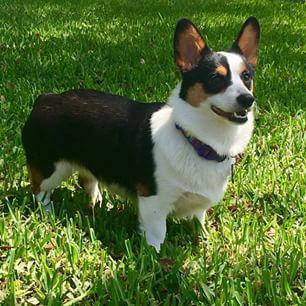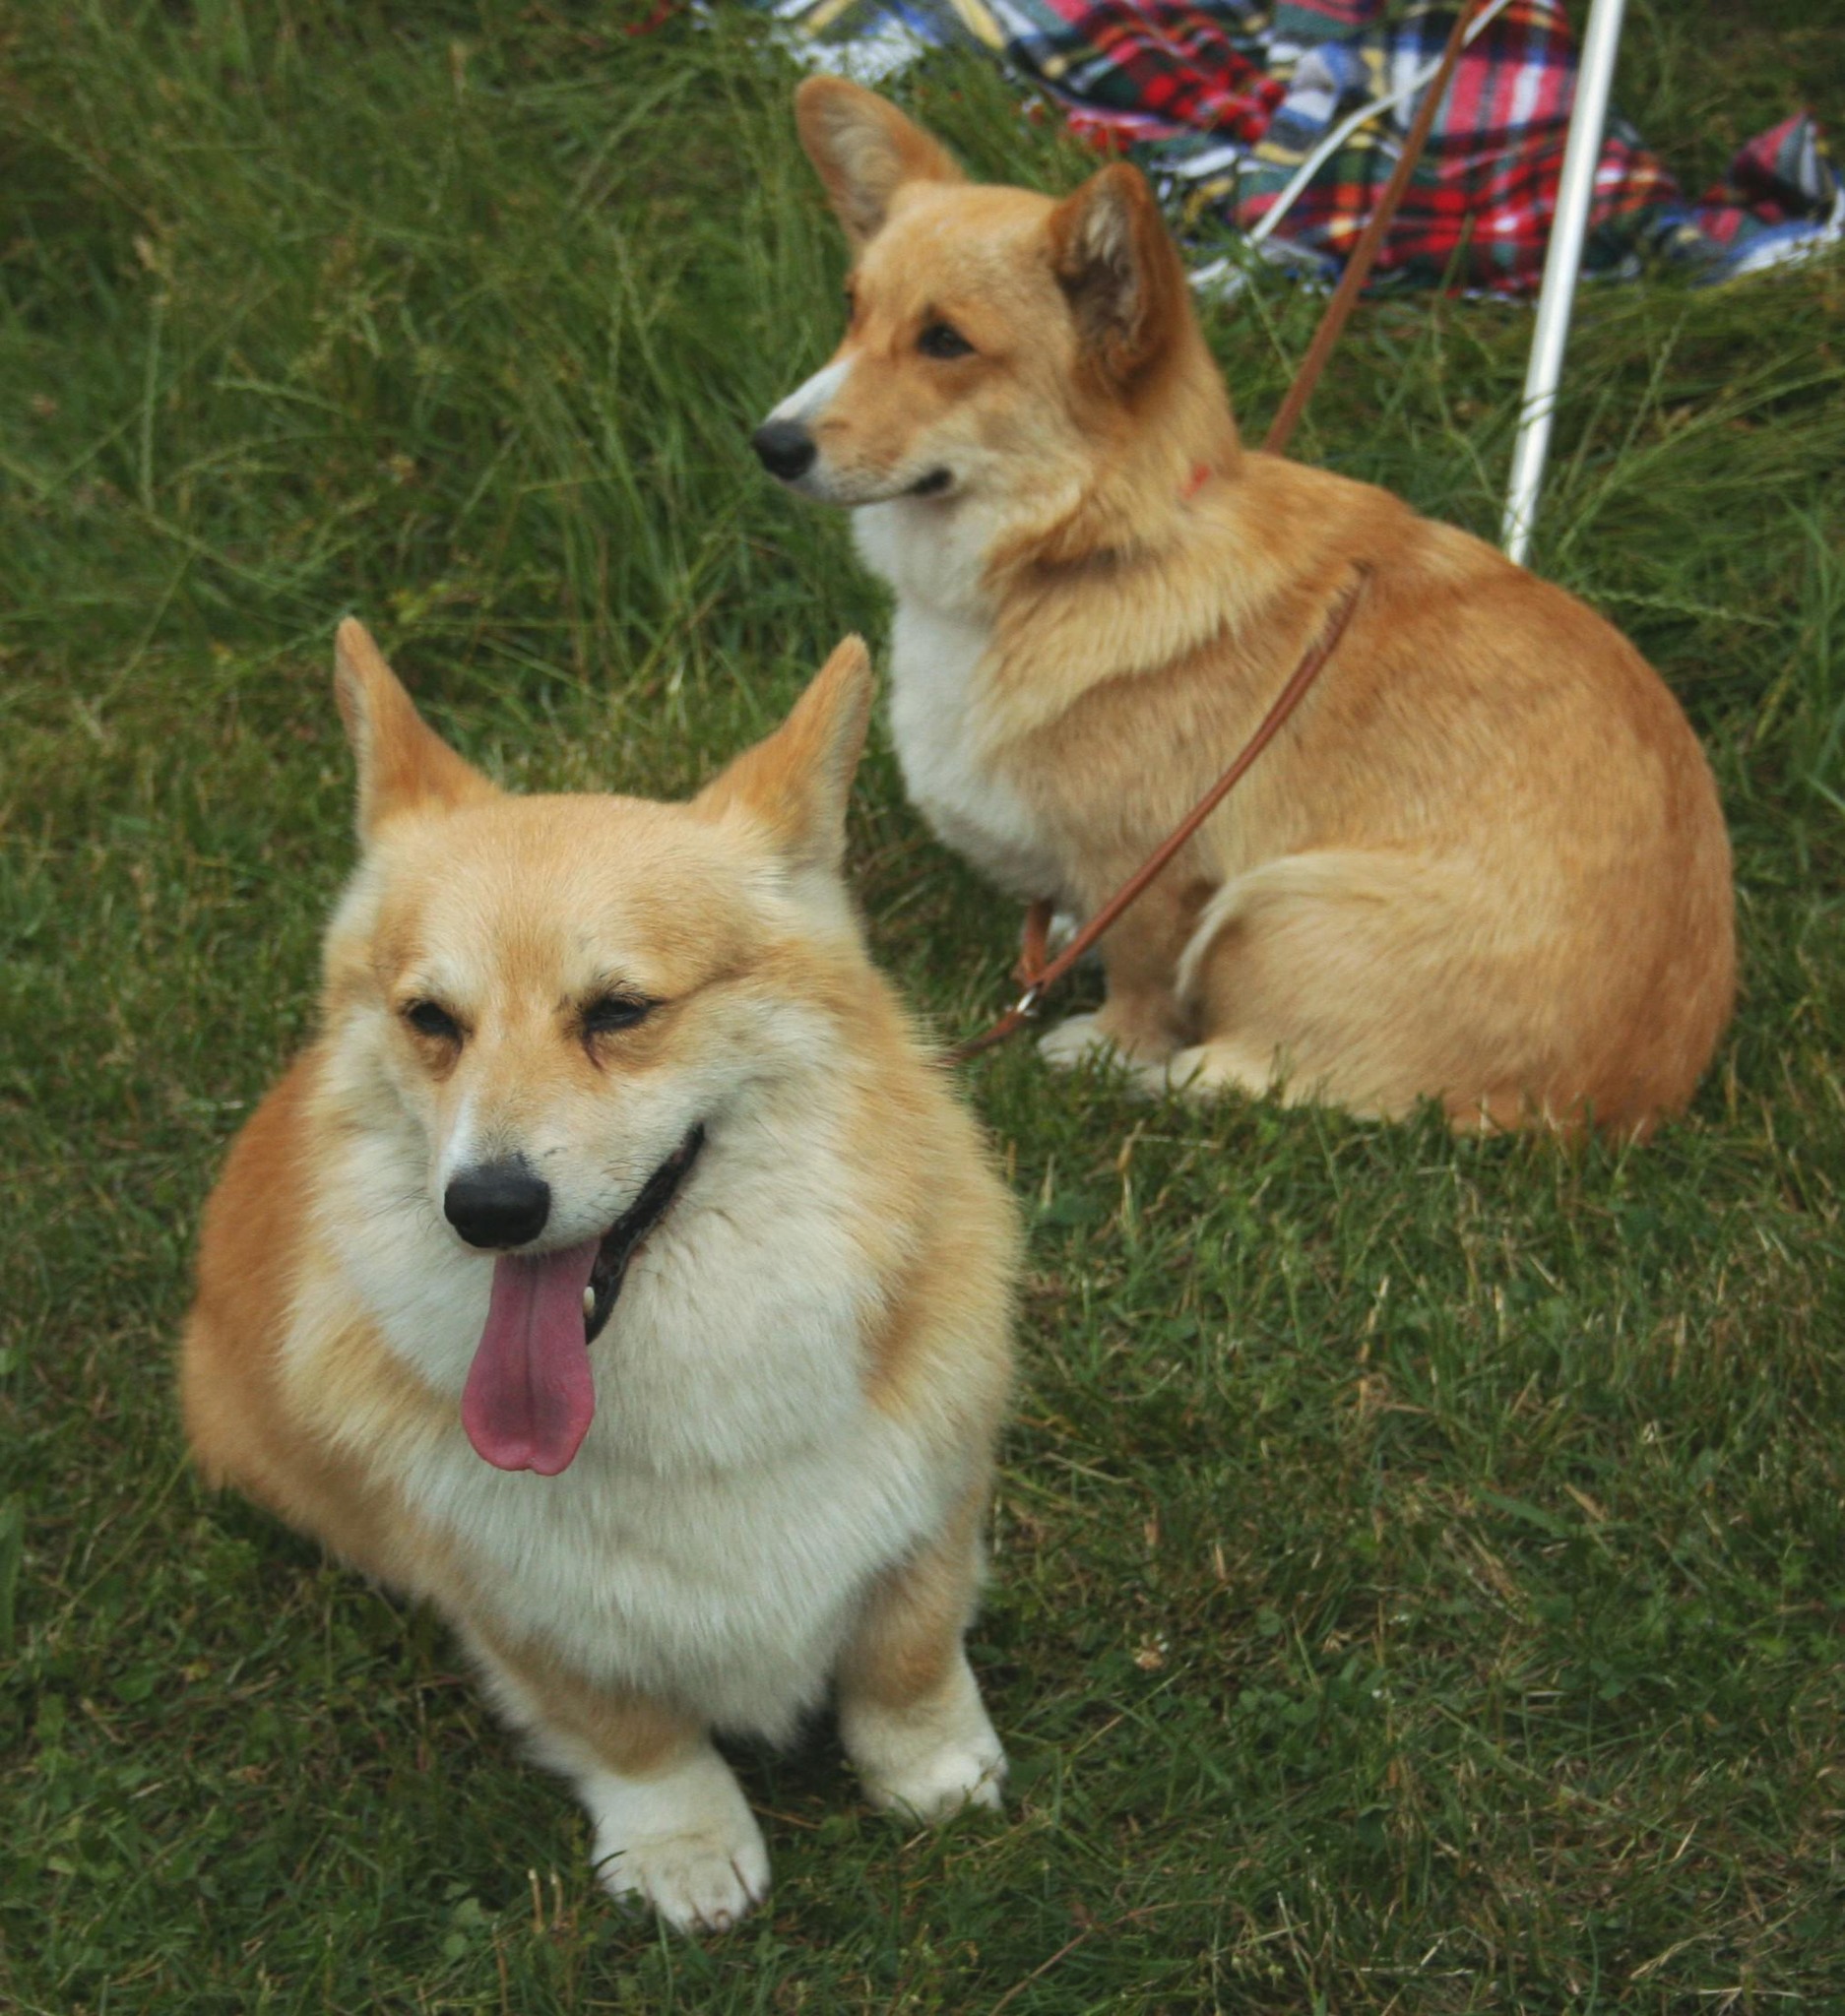The first image is the image on the left, the second image is the image on the right. Evaluate the accuracy of this statement regarding the images: "The dog in the left image has its tongue out.". Is it true? Answer yes or no. No. The first image is the image on the left, the second image is the image on the right. Given the left and right images, does the statement "Each image contains one orange-and-white corgi dog, each of the depicted dogs has its face turned forward." hold true? Answer yes or no. No. 